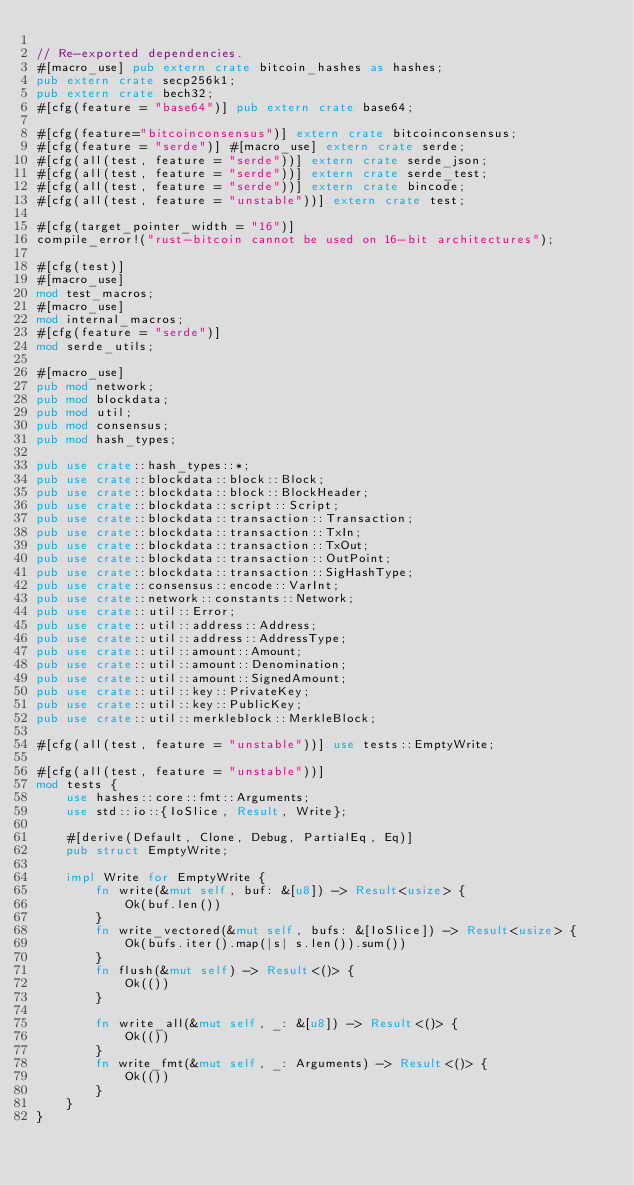<code> <loc_0><loc_0><loc_500><loc_500><_Rust_>
// Re-exported dependencies.
#[macro_use] pub extern crate bitcoin_hashes as hashes;
pub extern crate secp256k1;
pub extern crate bech32;
#[cfg(feature = "base64")] pub extern crate base64;

#[cfg(feature="bitcoinconsensus")] extern crate bitcoinconsensus;
#[cfg(feature = "serde")] #[macro_use] extern crate serde;
#[cfg(all(test, feature = "serde"))] extern crate serde_json;
#[cfg(all(test, feature = "serde"))] extern crate serde_test;
#[cfg(all(test, feature = "serde"))] extern crate bincode;
#[cfg(all(test, feature = "unstable"))] extern crate test;

#[cfg(target_pointer_width = "16")]
compile_error!("rust-bitcoin cannot be used on 16-bit architectures");

#[cfg(test)]
#[macro_use]
mod test_macros;
#[macro_use]
mod internal_macros;
#[cfg(feature = "serde")]
mod serde_utils;

#[macro_use]
pub mod network;
pub mod blockdata;
pub mod util;
pub mod consensus;
pub mod hash_types;

pub use crate::hash_types::*;
pub use crate::blockdata::block::Block;
pub use crate::blockdata::block::BlockHeader;
pub use crate::blockdata::script::Script;
pub use crate::blockdata::transaction::Transaction;
pub use crate::blockdata::transaction::TxIn;
pub use crate::blockdata::transaction::TxOut;
pub use crate::blockdata::transaction::OutPoint;
pub use crate::blockdata::transaction::SigHashType;
pub use crate::consensus::encode::VarInt;
pub use crate::network::constants::Network;
pub use crate::util::Error;
pub use crate::util::address::Address;
pub use crate::util::address::AddressType;
pub use crate::util::amount::Amount;
pub use crate::util::amount::Denomination;
pub use crate::util::amount::SignedAmount;
pub use crate::util::key::PrivateKey;
pub use crate::util::key::PublicKey;
pub use crate::util::merkleblock::MerkleBlock;

#[cfg(all(test, feature = "unstable"))] use tests::EmptyWrite;

#[cfg(all(test, feature = "unstable"))]
mod tests {
    use hashes::core::fmt::Arguments;
    use std::io::{IoSlice, Result, Write};

    #[derive(Default, Clone, Debug, PartialEq, Eq)]
    pub struct EmptyWrite;

    impl Write for EmptyWrite {
        fn write(&mut self, buf: &[u8]) -> Result<usize> {
            Ok(buf.len())
        }
        fn write_vectored(&mut self, bufs: &[IoSlice]) -> Result<usize> {
            Ok(bufs.iter().map(|s| s.len()).sum())
        }
        fn flush(&mut self) -> Result<()> {
            Ok(())
        }

        fn write_all(&mut self, _: &[u8]) -> Result<()> {
            Ok(())
        }
        fn write_fmt(&mut self, _: Arguments) -> Result<()> {
            Ok(())
        }
    }
}
</code> 